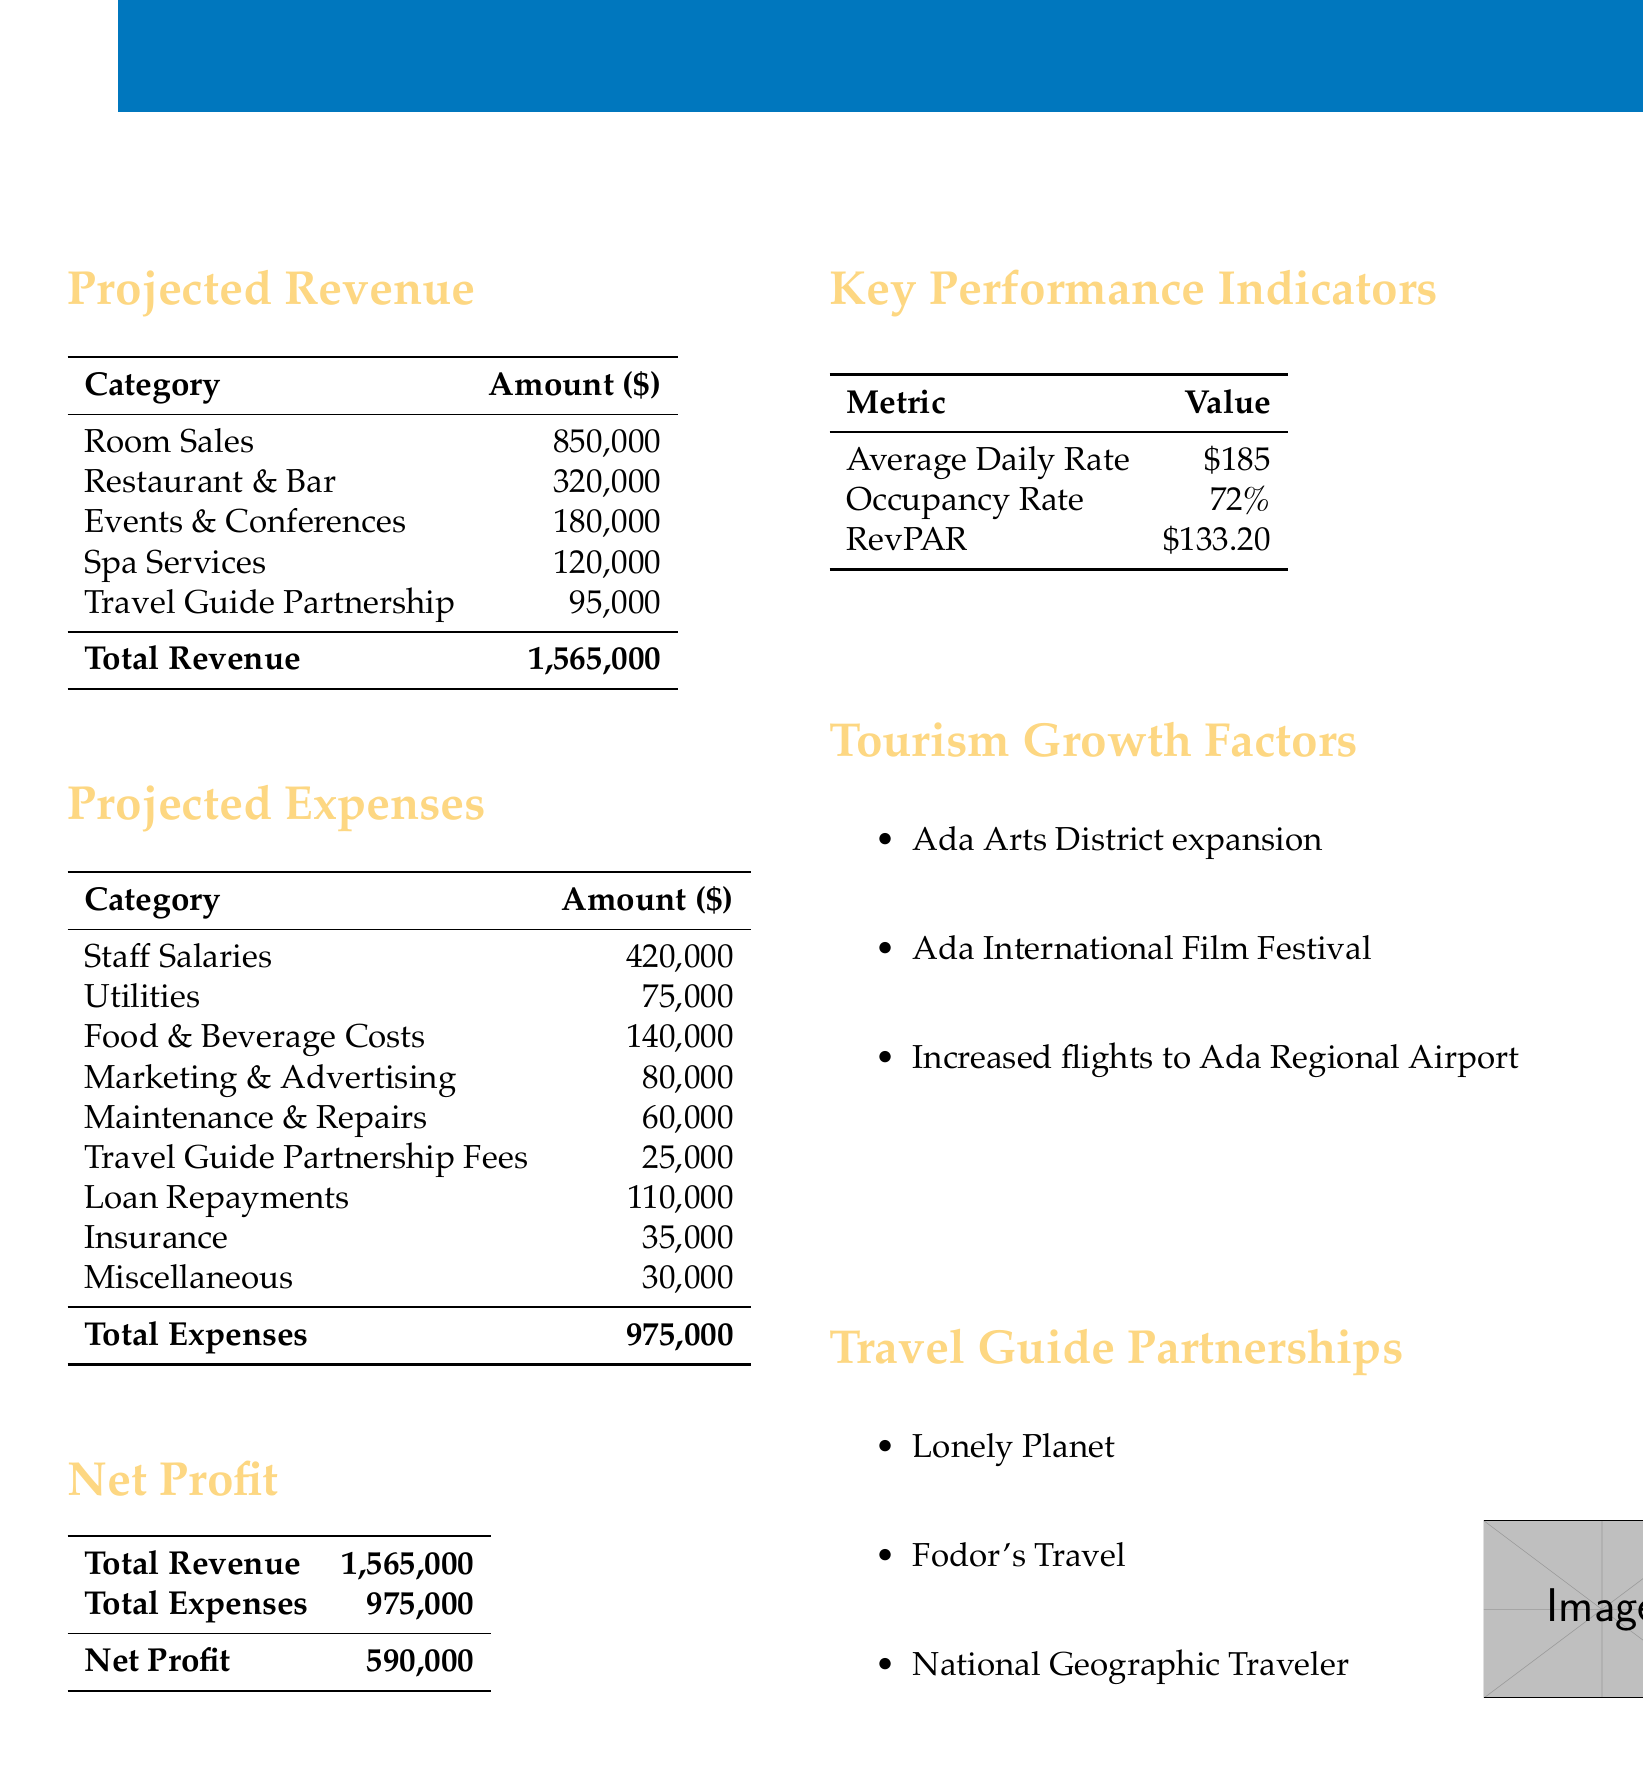what is the total revenue? The total revenue is calculated by adding all projected revenue categories, which totals to $1,565,000.
Answer: $1,565,000 what are the projected spa services revenue? The projected revenue from spa services is specifically mentioned as $120,000 in the revenue table.
Answer: $120,000 what is the amount allocated for marketing and advertising expenses? The document specifies the marketing and advertising expenses at $80,000.
Answer: $80,000 what is the net profit for the Ada Oasis Boutique Hotel? The net profit is the difference between total revenue and total expenses, which is $590,000.
Answer: $590,000 which travel guide partnerships are listed? The document lists three specific travel guide partnerships: Lonely Planet, Fodor's Travel, and National Geographic Traveler.
Answer: Lonely Planet, Fodor's Travel, National Geographic Traveler what are the average daily rate and occupancy rate? The average daily rate is $185 and the occupancy rate is 72%, both of which are key performance indicators provided in the document.
Answer: $185, 72% what is the total expense amount? The total expenses are calculated by summing all the categories in the expense table, which equals $975,000.
Answer: $975,000 how much revenue is projected from travel guide partnerships? The specific revenue projected from travel guide partnerships is stated as $95,000.
Answer: $95,000 what is the total for staff salaries? Staff salaries are explicitly mentioned in the expenses section as $420,000.
Answer: $420,000 what factors contribute to tourism growth? The document outlines three factors contributing to tourism growth: Ada Arts District expansion, Ada International Film Festival, and increased flights to Ada Regional Airport.
Answer: Ada Arts District expansion, Ada International Film Festival, increased flights to Ada Regional Airport 